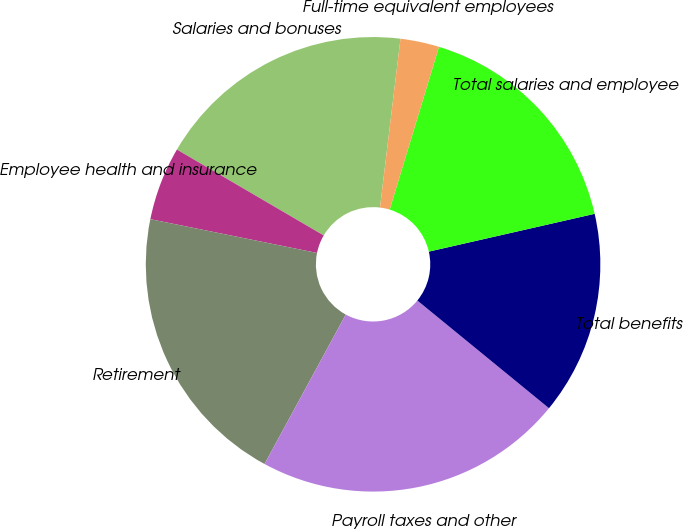Convert chart to OTSL. <chart><loc_0><loc_0><loc_500><loc_500><pie_chart><fcel>Salaries and bonuses<fcel>Employee health and insurance<fcel>Retirement<fcel>Payroll taxes and other<fcel>Total benefits<fcel>Total salaries and employee<fcel>Full-time equivalent employees<nl><fcel>18.5%<fcel>5.24%<fcel>20.26%<fcel>22.01%<fcel>14.48%<fcel>16.75%<fcel>2.76%<nl></chart> 